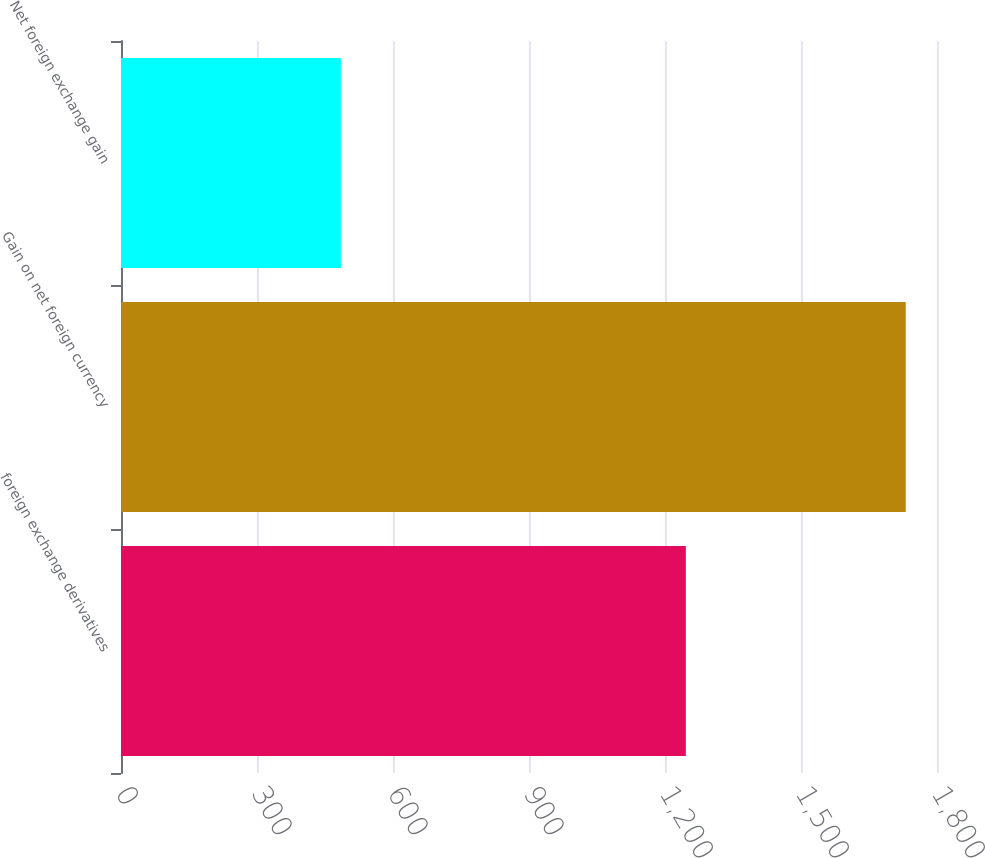Convert chart. <chart><loc_0><loc_0><loc_500><loc_500><bar_chart><fcel>foreign exchange derivatives<fcel>Gain on net foreign currency<fcel>Net foreign exchange gain<nl><fcel>1246<fcel>1731<fcel>485<nl></chart> 